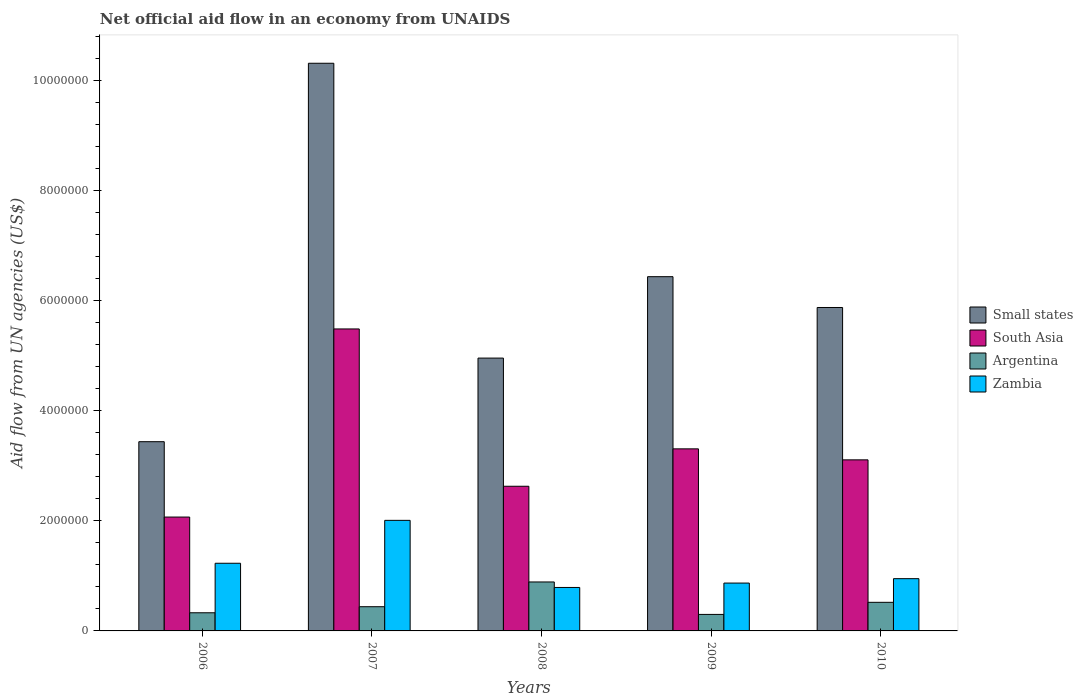Are the number of bars per tick equal to the number of legend labels?
Provide a succinct answer. Yes. Are the number of bars on each tick of the X-axis equal?
Your answer should be compact. Yes. What is the label of the 3rd group of bars from the left?
Keep it short and to the point. 2008. What is the net official aid flow in South Asia in 2007?
Make the answer very short. 5.49e+06. Across all years, what is the maximum net official aid flow in Argentina?
Give a very brief answer. 8.90e+05. Across all years, what is the minimum net official aid flow in Zambia?
Keep it short and to the point. 7.90e+05. What is the total net official aid flow in South Asia in the graph?
Provide a succinct answer. 1.66e+07. What is the difference between the net official aid flow in South Asia in 2007 and that in 2010?
Keep it short and to the point. 2.38e+06. What is the difference between the net official aid flow in Zambia in 2008 and the net official aid flow in Small states in 2006?
Ensure brevity in your answer.  -2.65e+06. What is the average net official aid flow in Zambia per year?
Make the answer very short. 1.17e+06. In the year 2007, what is the difference between the net official aid flow in Argentina and net official aid flow in Zambia?
Your answer should be very brief. -1.57e+06. In how many years, is the net official aid flow in South Asia greater than 10000000 US$?
Make the answer very short. 0. What is the ratio of the net official aid flow in South Asia in 2006 to that in 2008?
Offer a terse response. 0.79. Is the net official aid flow in Small states in 2006 less than that in 2008?
Give a very brief answer. Yes. What is the difference between the highest and the second highest net official aid flow in Small states?
Make the answer very short. 3.88e+06. What is the difference between the highest and the lowest net official aid flow in Argentina?
Provide a short and direct response. 5.90e+05. What does the 4th bar from the right in 2006 represents?
Your answer should be compact. Small states. How many bars are there?
Make the answer very short. 20. How many years are there in the graph?
Keep it short and to the point. 5. What is the difference between two consecutive major ticks on the Y-axis?
Keep it short and to the point. 2.00e+06. Where does the legend appear in the graph?
Ensure brevity in your answer.  Center right. What is the title of the graph?
Offer a terse response. Net official aid flow in an economy from UNAIDS. Does "Netherlands" appear as one of the legend labels in the graph?
Offer a very short reply. No. What is the label or title of the Y-axis?
Your response must be concise. Aid flow from UN agencies (US$). What is the Aid flow from UN agencies (US$) of Small states in 2006?
Offer a terse response. 3.44e+06. What is the Aid flow from UN agencies (US$) in South Asia in 2006?
Your answer should be compact. 2.07e+06. What is the Aid flow from UN agencies (US$) of Argentina in 2006?
Provide a short and direct response. 3.30e+05. What is the Aid flow from UN agencies (US$) in Zambia in 2006?
Give a very brief answer. 1.23e+06. What is the Aid flow from UN agencies (US$) of Small states in 2007?
Your answer should be compact. 1.03e+07. What is the Aid flow from UN agencies (US$) of South Asia in 2007?
Your response must be concise. 5.49e+06. What is the Aid flow from UN agencies (US$) of Argentina in 2007?
Ensure brevity in your answer.  4.40e+05. What is the Aid flow from UN agencies (US$) of Zambia in 2007?
Your answer should be compact. 2.01e+06. What is the Aid flow from UN agencies (US$) in Small states in 2008?
Offer a very short reply. 4.96e+06. What is the Aid flow from UN agencies (US$) of South Asia in 2008?
Give a very brief answer. 2.63e+06. What is the Aid flow from UN agencies (US$) of Argentina in 2008?
Make the answer very short. 8.90e+05. What is the Aid flow from UN agencies (US$) in Zambia in 2008?
Offer a terse response. 7.90e+05. What is the Aid flow from UN agencies (US$) in Small states in 2009?
Provide a short and direct response. 6.44e+06. What is the Aid flow from UN agencies (US$) in South Asia in 2009?
Offer a very short reply. 3.31e+06. What is the Aid flow from UN agencies (US$) of Zambia in 2009?
Offer a terse response. 8.70e+05. What is the Aid flow from UN agencies (US$) of Small states in 2010?
Your answer should be very brief. 5.88e+06. What is the Aid flow from UN agencies (US$) in South Asia in 2010?
Provide a succinct answer. 3.11e+06. What is the Aid flow from UN agencies (US$) in Argentina in 2010?
Your answer should be compact. 5.20e+05. What is the Aid flow from UN agencies (US$) in Zambia in 2010?
Keep it short and to the point. 9.50e+05. Across all years, what is the maximum Aid flow from UN agencies (US$) in Small states?
Make the answer very short. 1.03e+07. Across all years, what is the maximum Aid flow from UN agencies (US$) of South Asia?
Your response must be concise. 5.49e+06. Across all years, what is the maximum Aid flow from UN agencies (US$) in Argentina?
Make the answer very short. 8.90e+05. Across all years, what is the maximum Aid flow from UN agencies (US$) in Zambia?
Ensure brevity in your answer.  2.01e+06. Across all years, what is the minimum Aid flow from UN agencies (US$) in Small states?
Give a very brief answer. 3.44e+06. Across all years, what is the minimum Aid flow from UN agencies (US$) of South Asia?
Your answer should be very brief. 2.07e+06. Across all years, what is the minimum Aid flow from UN agencies (US$) in Argentina?
Provide a short and direct response. 3.00e+05. Across all years, what is the minimum Aid flow from UN agencies (US$) in Zambia?
Provide a succinct answer. 7.90e+05. What is the total Aid flow from UN agencies (US$) in Small states in the graph?
Offer a terse response. 3.10e+07. What is the total Aid flow from UN agencies (US$) in South Asia in the graph?
Your response must be concise. 1.66e+07. What is the total Aid flow from UN agencies (US$) in Argentina in the graph?
Give a very brief answer. 2.48e+06. What is the total Aid flow from UN agencies (US$) of Zambia in the graph?
Provide a short and direct response. 5.85e+06. What is the difference between the Aid flow from UN agencies (US$) in Small states in 2006 and that in 2007?
Give a very brief answer. -6.88e+06. What is the difference between the Aid flow from UN agencies (US$) in South Asia in 2006 and that in 2007?
Offer a terse response. -3.42e+06. What is the difference between the Aid flow from UN agencies (US$) of Argentina in 2006 and that in 2007?
Make the answer very short. -1.10e+05. What is the difference between the Aid flow from UN agencies (US$) in Zambia in 2006 and that in 2007?
Ensure brevity in your answer.  -7.80e+05. What is the difference between the Aid flow from UN agencies (US$) of Small states in 2006 and that in 2008?
Your answer should be compact. -1.52e+06. What is the difference between the Aid flow from UN agencies (US$) in South Asia in 2006 and that in 2008?
Your answer should be very brief. -5.60e+05. What is the difference between the Aid flow from UN agencies (US$) of Argentina in 2006 and that in 2008?
Keep it short and to the point. -5.60e+05. What is the difference between the Aid flow from UN agencies (US$) in Zambia in 2006 and that in 2008?
Offer a very short reply. 4.40e+05. What is the difference between the Aid flow from UN agencies (US$) in South Asia in 2006 and that in 2009?
Provide a succinct answer. -1.24e+06. What is the difference between the Aid flow from UN agencies (US$) in Small states in 2006 and that in 2010?
Make the answer very short. -2.44e+06. What is the difference between the Aid flow from UN agencies (US$) of South Asia in 2006 and that in 2010?
Your answer should be compact. -1.04e+06. What is the difference between the Aid flow from UN agencies (US$) of Argentina in 2006 and that in 2010?
Your answer should be compact. -1.90e+05. What is the difference between the Aid flow from UN agencies (US$) of Zambia in 2006 and that in 2010?
Make the answer very short. 2.80e+05. What is the difference between the Aid flow from UN agencies (US$) in Small states in 2007 and that in 2008?
Your answer should be compact. 5.36e+06. What is the difference between the Aid flow from UN agencies (US$) in South Asia in 2007 and that in 2008?
Give a very brief answer. 2.86e+06. What is the difference between the Aid flow from UN agencies (US$) of Argentina in 2007 and that in 2008?
Keep it short and to the point. -4.50e+05. What is the difference between the Aid flow from UN agencies (US$) of Zambia in 2007 and that in 2008?
Your response must be concise. 1.22e+06. What is the difference between the Aid flow from UN agencies (US$) in Small states in 2007 and that in 2009?
Your answer should be very brief. 3.88e+06. What is the difference between the Aid flow from UN agencies (US$) in South Asia in 2007 and that in 2009?
Your answer should be very brief. 2.18e+06. What is the difference between the Aid flow from UN agencies (US$) of Zambia in 2007 and that in 2009?
Provide a succinct answer. 1.14e+06. What is the difference between the Aid flow from UN agencies (US$) in Small states in 2007 and that in 2010?
Make the answer very short. 4.44e+06. What is the difference between the Aid flow from UN agencies (US$) in South Asia in 2007 and that in 2010?
Offer a very short reply. 2.38e+06. What is the difference between the Aid flow from UN agencies (US$) of Zambia in 2007 and that in 2010?
Provide a succinct answer. 1.06e+06. What is the difference between the Aid flow from UN agencies (US$) in Small states in 2008 and that in 2009?
Give a very brief answer. -1.48e+06. What is the difference between the Aid flow from UN agencies (US$) of South Asia in 2008 and that in 2009?
Ensure brevity in your answer.  -6.80e+05. What is the difference between the Aid flow from UN agencies (US$) in Argentina in 2008 and that in 2009?
Offer a very short reply. 5.90e+05. What is the difference between the Aid flow from UN agencies (US$) in Zambia in 2008 and that in 2009?
Offer a terse response. -8.00e+04. What is the difference between the Aid flow from UN agencies (US$) of Small states in 2008 and that in 2010?
Keep it short and to the point. -9.20e+05. What is the difference between the Aid flow from UN agencies (US$) in South Asia in 2008 and that in 2010?
Offer a terse response. -4.80e+05. What is the difference between the Aid flow from UN agencies (US$) in Small states in 2009 and that in 2010?
Provide a succinct answer. 5.60e+05. What is the difference between the Aid flow from UN agencies (US$) in South Asia in 2009 and that in 2010?
Give a very brief answer. 2.00e+05. What is the difference between the Aid flow from UN agencies (US$) in Zambia in 2009 and that in 2010?
Your response must be concise. -8.00e+04. What is the difference between the Aid flow from UN agencies (US$) of Small states in 2006 and the Aid flow from UN agencies (US$) of South Asia in 2007?
Offer a terse response. -2.05e+06. What is the difference between the Aid flow from UN agencies (US$) in Small states in 2006 and the Aid flow from UN agencies (US$) in Zambia in 2007?
Offer a very short reply. 1.43e+06. What is the difference between the Aid flow from UN agencies (US$) in South Asia in 2006 and the Aid flow from UN agencies (US$) in Argentina in 2007?
Give a very brief answer. 1.63e+06. What is the difference between the Aid flow from UN agencies (US$) of South Asia in 2006 and the Aid flow from UN agencies (US$) of Zambia in 2007?
Offer a very short reply. 6.00e+04. What is the difference between the Aid flow from UN agencies (US$) in Argentina in 2006 and the Aid flow from UN agencies (US$) in Zambia in 2007?
Your answer should be very brief. -1.68e+06. What is the difference between the Aid flow from UN agencies (US$) in Small states in 2006 and the Aid flow from UN agencies (US$) in South Asia in 2008?
Give a very brief answer. 8.10e+05. What is the difference between the Aid flow from UN agencies (US$) of Small states in 2006 and the Aid flow from UN agencies (US$) of Argentina in 2008?
Give a very brief answer. 2.55e+06. What is the difference between the Aid flow from UN agencies (US$) of Small states in 2006 and the Aid flow from UN agencies (US$) of Zambia in 2008?
Your response must be concise. 2.65e+06. What is the difference between the Aid flow from UN agencies (US$) of South Asia in 2006 and the Aid flow from UN agencies (US$) of Argentina in 2008?
Keep it short and to the point. 1.18e+06. What is the difference between the Aid flow from UN agencies (US$) of South Asia in 2006 and the Aid flow from UN agencies (US$) of Zambia in 2008?
Your response must be concise. 1.28e+06. What is the difference between the Aid flow from UN agencies (US$) of Argentina in 2006 and the Aid flow from UN agencies (US$) of Zambia in 2008?
Your answer should be very brief. -4.60e+05. What is the difference between the Aid flow from UN agencies (US$) of Small states in 2006 and the Aid flow from UN agencies (US$) of South Asia in 2009?
Your response must be concise. 1.30e+05. What is the difference between the Aid flow from UN agencies (US$) in Small states in 2006 and the Aid flow from UN agencies (US$) in Argentina in 2009?
Offer a very short reply. 3.14e+06. What is the difference between the Aid flow from UN agencies (US$) in Small states in 2006 and the Aid flow from UN agencies (US$) in Zambia in 2009?
Give a very brief answer. 2.57e+06. What is the difference between the Aid flow from UN agencies (US$) of South Asia in 2006 and the Aid flow from UN agencies (US$) of Argentina in 2009?
Provide a short and direct response. 1.77e+06. What is the difference between the Aid flow from UN agencies (US$) in South Asia in 2006 and the Aid flow from UN agencies (US$) in Zambia in 2009?
Keep it short and to the point. 1.20e+06. What is the difference between the Aid flow from UN agencies (US$) of Argentina in 2006 and the Aid flow from UN agencies (US$) of Zambia in 2009?
Offer a very short reply. -5.40e+05. What is the difference between the Aid flow from UN agencies (US$) of Small states in 2006 and the Aid flow from UN agencies (US$) of Argentina in 2010?
Provide a succinct answer. 2.92e+06. What is the difference between the Aid flow from UN agencies (US$) in Small states in 2006 and the Aid flow from UN agencies (US$) in Zambia in 2010?
Keep it short and to the point. 2.49e+06. What is the difference between the Aid flow from UN agencies (US$) in South Asia in 2006 and the Aid flow from UN agencies (US$) in Argentina in 2010?
Your answer should be very brief. 1.55e+06. What is the difference between the Aid flow from UN agencies (US$) of South Asia in 2006 and the Aid flow from UN agencies (US$) of Zambia in 2010?
Offer a terse response. 1.12e+06. What is the difference between the Aid flow from UN agencies (US$) of Argentina in 2006 and the Aid flow from UN agencies (US$) of Zambia in 2010?
Keep it short and to the point. -6.20e+05. What is the difference between the Aid flow from UN agencies (US$) in Small states in 2007 and the Aid flow from UN agencies (US$) in South Asia in 2008?
Your response must be concise. 7.69e+06. What is the difference between the Aid flow from UN agencies (US$) of Small states in 2007 and the Aid flow from UN agencies (US$) of Argentina in 2008?
Provide a short and direct response. 9.43e+06. What is the difference between the Aid flow from UN agencies (US$) of Small states in 2007 and the Aid flow from UN agencies (US$) of Zambia in 2008?
Your answer should be very brief. 9.53e+06. What is the difference between the Aid flow from UN agencies (US$) in South Asia in 2007 and the Aid flow from UN agencies (US$) in Argentina in 2008?
Provide a short and direct response. 4.60e+06. What is the difference between the Aid flow from UN agencies (US$) in South Asia in 2007 and the Aid flow from UN agencies (US$) in Zambia in 2008?
Offer a very short reply. 4.70e+06. What is the difference between the Aid flow from UN agencies (US$) in Argentina in 2007 and the Aid flow from UN agencies (US$) in Zambia in 2008?
Your response must be concise. -3.50e+05. What is the difference between the Aid flow from UN agencies (US$) of Small states in 2007 and the Aid flow from UN agencies (US$) of South Asia in 2009?
Offer a terse response. 7.01e+06. What is the difference between the Aid flow from UN agencies (US$) in Small states in 2007 and the Aid flow from UN agencies (US$) in Argentina in 2009?
Provide a short and direct response. 1.00e+07. What is the difference between the Aid flow from UN agencies (US$) of Small states in 2007 and the Aid flow from UN agencies (US$) of Zambia in 2009?
Your answer should be compact. 9.45e+06. What is the difference between the Aid flow from UN agencies (US$) in South Asia in 2007 and the Aid flow from UN agencies (US$) in Argentina in 2009?
Provide a succinct answer. 5.19e+06. What is the difference between the Aid flow from UN agencies (US$) in South Asia in 2007 and the Aid flow from UN agencies (US$) in Zambia in 2009?
Keep it short and to the point. 4.62e+06. What is the difference between the Aid flow from UN agencies (US$) in Argentina in 2007 and the Aid flow from UN agencies (US$) in Zambia in 2009?
Give a very brief answer. -4.30e+05. What is the difference between the Aid flow from UN agencies (US$) of Small states in 2007 and the Aid flow from UN agencies (US$) of South Asia in 2010?
Give a very brief answer. 7.21e+06. What is the difference between the Aid flow from UN agencies (US$) of Small states in 2007 and the Aid flow from UN agencies (US$) of Argentina in 2010?
Your response must be concise. 9.80e+06. What is the difference between the Aid flow from UN agencies (US$) of Small states in 2007 and the Aid flow from UN agencies (US$) of Zambia in 2010?
Give a very brief answer. 9.37e+06. What is the difference between the Aid flow from UN agencies (US$) in South Asia in 2007 and the Aid flow from UN agencies (US$) in Argentina in 2010?
Provide a short and direct response. 4.97e+06. What is the difference between the Aid flow from UN agencies (US$) in South Asia in 2007 and the Aid flow from UN agencies (US$) in Zambia in 2010?
Offer a very short reply. 4.54e+06. What is the difference between the Aid flow from UN agencies (US$) of Argentina in 2007 and the Aid flow from UN agencies (US$) of Zambia in 2010?
Give a very brief answer. -5.10e+05. What is the difference between the Aid flow from UN agencies (US$) in Small states in 2008 and the Aid flow from UN agencies (US$) in South Asia in 2009?
Your answer should be compact. 1.65e+06. What is the difference between the Aid flow from UN agencies (US$) of Small states in 2008 and the Aid flow from UN agencies (US$) of Argentina in 2009?
Ensure brevity in your answer.  4.66e+06. What is the difference between the Aid flow from UN agencies (US$) in Small states in 2008 and the Aid flow from UN agencies (US$) in Zambia in 2009?
Ensure brevity in your answer.  4.09e+06. What is the difference between the Aid flow from UN agencies (US$) in South Asia in 2008 and the Aid flow from UN agencies (US$) in Argentina in 2009?
Make the answer very short. 2.33e+06. What is the difference between the Aid flow from UN agencies (US$) in South Asia in 2008 and the Aid flow from UN agencies (US$) in Zambia in 2009?
Ensure brevity in your answer.  1.76e+06. What is the difference between the Aid flow from UN agencies (US$) in Argentina in 2008 and the Aid flow from UN agencies (US$) in Zambia in 2009?
Your response must be concise. 2.00e+04. What is the difference between the Aid flow from UN agencies (US$) in Small states in 2008 and the Aid flow from UN agencies (US$) in South Asia in 2010?
Offer a terse response. 1.85e+06. What is the difference between the Aid flow from UN agencies (US$) of Small states in 2008 and the Aid flow from UN agencies (US$) of Argentina in 2010?
Your answer should be compact. 4.44e+06. What is the difference between the Aid flow from UN agencies (US$) in Small states in 2008 and the Aid flow from UN agencies (US$) in Zambia in 2010?
Your answer should be very brief. 4.01e+06. What is the difference between the Aid flow from UN agencies (US$) of South Asia in 2008 and the Aid flow from UN agencies (US$) of Argentina in 2010?
Keep it short and to the point. 2.11e+06. What is the difference between the Aid flow from UN agencies (US$) of South Asia in 2008 and the Aid flow from UN agencies (US$) of Zambia in 2010?
Offer a very short reply. 1.68e+06. What is the difference between the Aid flow from UN agencies (US$) in Small states in 2009 and the Aid flow from UN agencies (US$) in South Asia in 2010?
Ensure brevity in your answer.  3.33e+06. What is the difference between the Aid flow from UN agencies (US$) in Small states in 2009 and the Aid flow from UN agencies (US$) in Argentina in 2010?
Give a very brief answer. 5.92e+06. What is the difference between the Aid flow from UN agencies (US$) of Small states in 2009 and the Aid flow from UN agencies (US$) of Zambia in 2010?
Ensure brevity in your answer.  5.49e+06. What is the difference between the Aid flow from UN agencies (US$) of South Asia in 2009 and the Aid flow from UN agencies (US$) of Argentina in 2010?
Provide a succinct answer. 2.79e+06. What is the difference between the Aid flow from UN agencies (US$) in South Asia in 2009 and the Aid flow from UN agencies (US$) in Zambia in 2010?
Offer a terse response. 2.36e+06. What is the difference between the Aid flow from UN agencies (US$) in Argentina in 2009 and the Aid flow from UN agencies (US$) in Zambia in 2010?
Your answer should be compact. -6.50e+05. What is the average Aid flow from UN agencies (US$) of Small states per year?
Your answer should be compact. 6.21e+06. What is the average Aid flow from UN agencies (US$) in South Asia per year?
Offer a terse response. 3.32e+06. What is the average Aid flow from UN agencies (US$) of Argentina per year?
Your answer should be compact. 4.96e+05. What is the average Aid flow from UN agencies (US$) in Zambia per year?
Your answer should be very brief. 1.17e+06. In the year 2006, what is the difference between the Aid flow from UN agencies (US$) in Small states and Aid flow from UN agencies (US$) in South Asia?
Ensure brevity in your answer.  1.37e+06. In the year 2006, what is the difference between the Aid flow from UN agencies (US$) of Small states and Aid flow from UN agencies (US$) of Argentina?
Offer a terse response. 3.11e+06. In the year 2006, what is the difference between the Aid flow from UN agencies (US$) of Small states and Aid flow from UN agencies (US$) of Zambia?
Provide a succinct answer. 2.21e+06. In the year 2006, what is the difference between the Aid flow from UN agencies (US$) in South Asia and Aid flow from UN agencies (US$) in Argentina?
Your answer should be compact. 1.74e+06. In the year 2006, what is the difference between the Aid flow from UN agencies (US$) in South Asia and Aid flow from UN agencies (US$) in Zambia?
Your answer should be compact. 8.40e+05. In the year 2006, what is the difference between the Aid flow from UN agencies (US$) of Argentina and Aid flow from UN agencies (US$) of Zambia?
Provide a succinct answer. -9.00e+05. In the year 2007, what is the difference between the Aid flow from UN agencies (US$) in Small states and Aid flow from UN agencies (US$) in South Asia?
Give a very brief answer. 4.83e+06. In the year 2007, what is the difference between the Aid flow from UN agencies (US$) in Small states and Aid flow from UN agencies (US$) in Argentina?
Keep it short and to the point. 9.88e+06. In the year 2007, what is the difference between the Aid flow from UN agencies (US$) of Small states and Aid flow from UN agencies (US$) of Zambia?
Your answer should be very brief. 8.31e+06. In the year 2007, what is the difference between the Aid flow from UN agencies (US$) in South Asia and Aid flow from UN agencies (US$) in Argentina?
Your response must be concise. 5.05e+06. In the year 2007, what is the difference between the Aid flow from UN agencies (US$) in South Asia and Aid flow from UN agencies (US$) in Zambia?
Give a very brief answer. 3.48e+06. In the year 2007, what is the difference between the Aid flow from UN agencies (US$) of Argentina and Aid flow from UN agencies (US$) of Zambia?
Your answer should be very brief. -1.57e+06. In the year 2008, what is the difference between the Aid flow from UN agencies (US$) in Small states and Aid flow from UN agencies (US$) in South Asia?
Your response must be concise. 2.33e+06. In the year 2008, what is the difference between the Aid flow from UN agencies (US$) of Small states and Aid flow from UN agencies (US$) of Argentina?
Give a very brief answer. 4.07e+06. In the year 2008, what is the difference between the Aid flow from UN agencies (US$) of Small states and Aid flow from UN agencies (US$) of Zambia?
Keep it short and to the point. 4.17e+06. In the year 2008, what is the difference between the Aid flow from UN agencies (US$) of South Asia and Aid flow from UN agencies (US$) of Argentina?
Provide a succinct answer. 1.74e+06. In the year 2008, what is the difference between the Aid flow from UN agencies (US$) of South Asia and Aid flow from UN agencies (US$) of Zambia?
Keep it short and to the point. 1.84e+06. In the year 2009, what is the difference between the Aid flow from UN agencies (US$) in Small states and Aid flow from UN agencies (US$) in South Asia?
Provide a short and direct response. 3.13e+06. In the year 2009, what is the difference between the Aid flow from UN agencies (US$) of Small states and Aid flow from UN agencies (US$) of Argentina?
Provide a short and direct response. 6.14e+06. In the year 2009, what is the difference between the Aid flow from UN agencies (US$) of Small states and Aid flow from UN agencies (US$) of Zambia?
Provide a succinct answer. 5.57e+06. In the year 2009, what is the difference between the Aid flow from UN agencies (US$) of South Asia and Aid flow from UN agencies (US$) of Argentina?
Your answer should be very brief. 3.01e+06. In the year 2009, what is the difference between the Aid flow from UN agencies (US$) of South Asia and Aid flow from UN agencies (US$) of Zambia?
Offer a very short reply. 2.44e+06. In the year 2009, what is the difference between the Aid flow from UN agencies (US$) in Argentina and Aid flow from UN agencies (US$) in Zambia?
Your answer should be compact. -5.70e+05. In the year 2010, what is the difference between the Aid flow from UN agencies (US$) of Small states and Aid flow from UN agencies (US$) of South Asia?
Your response must be concise. 2.77e+06. In the year 2010, what is the difference between the Aid flow from UN agencies (US$) of Small states and Aid flow from UN agencies (US$) of Argentina?
Your response must be concise. 5.36e+06. In the year 2010, what is the difference between the Aid flow from UN agencies (US$) of Small states and Aid flow from UN agencies (US$) of Zambia?
Your answer should be compact. 4.93e+06. In the year 2010, what is the difference between the Aid flow from UN agencies (US$) of South Asia and Aid flow from UN agencies (US$) of Argentina?
Offer a terse response. 2.59e+06. In the year 2010, what is the difference between the Aid flow from UN agencies (US$) in South Asia and Aid flow from UN agencies (US$) in Zambia?
Keep it short and to the point. 2.16e+06. In the year 2010, what is the difference between the Aid flow from UN agencies (US$) of Argentina and Aid flow from UN agencies (US$) of Zambia?
Your answer should be very brief. -4.30e+05. What is the ratio of the Aid flow from UN agencies (US$) in Small states in 2006 to that in 2007?
Your answer should be very brief. 0.33. What is the ratio of the Aid flow from UN agencies (US$) of South Asia in 2006 to that in 2007?
Provide a succinct answer. 0.38. What is the ratio of the Aid flow from UN agencies (US$) in Zambia in 2006 to that in 2007?
Your answer should be compact. 0.61. What is the ratio of the Aid flow from UN agencies (US$) in Small states in 2006 to that in 2008?
Your answer should be compact. 0.69. What is the ratio of the Aid flow from UN agencies (US$) in South Asia in 2006 to that in 2008?
Give a very brief answer. 0.79. What is the ratio of the Aid flow from UN agencies (US$) in Argentina in 2006 to that in 2008?
Your answer should be compact. 0.37. What is the ratio of the Aid flow from UN agencies (US$) of Zambia in 2006 to that in 2008?
Ensure brevity in your answer.  1.56. What is the ratio of the Aid flow from UN agencies (US$) in Small states in 2006 to that in 2009?
Make the answer very short. 0.53. What is the ratio of the Aid flow from UN agencies (US$) of South Asia in 2006 to that in 2009?
Provide a succinct answer. 0.63. What is the ratio of the Aid flow from UN agencies (US$) of Argentina in 2006 to that in 2009?
Ensure brevity in your answer.  1.1. What is the ratio of the Aid flow from UN agencies (US$) of Zambia in 2006 to that in 2009?
Give a very brief answer. 1.41. What is the ratio of the Aid flow from UN agencies (US$) in Small states in 2006 to that in 2010?
Offer a very short reply. 0.58. What is the ratio of the Aid flow from UN agencies (US$) in South Asia in 2006 to that in 2010?
Give a very brief answer. 0.67. What is the ratio of the Aid flow from UN agencies (US$) of Argentina in 2006 to that in 2010?
Make the answer very short. 0.63. What is the ratio of the Aid flow from UN agencies (US$) in Zambia in 2006 to that in 2010?
Offer a very short reply. 1.29. What is the ratio of the Aid flow from UN agencies (US$) in Small states in 2007 to that in 2008?
Make the answer very short. 2.08. What is the ratio of the Aid flow from UN agencies (US$) of South Asia in 2007 to that in 2008?
Give a very brief answer. 2.09. What is the ratio of the Aid flow from UN agencies (US$) of Argentina in 2007 to that in 2008?
Ensure brevity in your answer.  0.49. What is the ratio of the Aid flow from UN agencies (US$) in Zambia in 2007 to that in 2008?
Keep it short and to the point. 2.54. What is the ratio of the Aid flow from UN agencies (US$) in Small states in 2007 to that in 2009?
Ensure brevity in your answer.  1.6. What is the ratio of the Aid flow from UN agencies (US$) of South Asia in 2007 to that in 2009?
Provide a short and direct response. 1.66. What is the ratio of the Aid flow from UN agencies (US$) of Argentina in 2007 to that in 2009?
Offer a very short reply. 1.47. What is the ratio of the Aid flow from UN agencies (US$) in Zambia in 2007 to that in 2009?
Offer a terse response. 2.31. What is the ratio of the Aid flow from UN agencies (US$) of Small states in 2007 to that in 2010?
Offer a very short reply. 1.76. What is the ratio of the Aid flow from UN agencies (US$) of South Asia in 2007 to that in 2010?
Your answer should be compact. 1.77. What is the ratio of the Aid flow from UN agencies (US$) of Argentina in 2007 to that in 2010?
Give a very brief answer. 0.85. What is the ratio of the Aid flow from UN agencies (US$) of Zambia in 2007 to that in 2010?
Offer a terse response. 2.12. What is the ratio of the Aid flow from UN agencies (US$) in Small states in 2008 to that in 2009?
Provide a short and direct response. 0.77. What is the ratio of the Aid flow from UN agencies (US$) of South Asia in 2008 to that in 2009?
Keep it short and to the point. 0.79. What is the ratio of the Aid flow from UN agencies (US$) in Argentina in 2008 to that in 2009?
Ensure brevity in your answer.  2.97. What is the ratio of the Aid flow from UN agencies (US$) in Zambia in 2008 to that in 2009?
Keep it short and to the point. 0.91. What is the ratio of the Aid flow from UN agencies (US$) of Small states in 2008 to that in 2010?
Give a very brief answer. 0.84. What is the ratio of the Aid flow from UN agencies (US$) in South Asia in 2008 to that in 2010?
Your answer should be very brief. 0.85. What is the ratio of the Aid flow from UN agencies (US$) in Argentina in 2008 to that in 2010?
Ensure brevity in your answer.  1.71. What is the ratio of the Aid flow from UN agencies (US$) of Zambia in 2008 to that in 2010?
Your answer should be very brief. 0.83. What is the ratio of the Aid flow from UN agencies (US$) in Small states in 2009 to that in 2010?
Offer a very short reply. 1.1. What is the ratio of the Aid flow from UN agencies (US$) of South Asia in 2009 to that in 2010?
Ensure brevity in your answer.  1.06. What is the ratio of the Aid flow from UN agencies (US$) in Argentina in 2009 to that in 2010?
Ensure brevity in your answer.  0.58. What is the ratio of the Aid flow from UN agencies (US$) of Zambia in 2009 to that in 2010?
Offer a terse response. 0.92. What is the difference between the highest and the second highest Aid flow from UN agencies (US$) of Small states?
Keep it short and to the point. 3.88e+06. What is the difference between the highest and the second highest Aid flow from UN agencies (US$) of South Asia?
Give a very brief answer. 2.18e+06. What is the difference between the highest and the second highest Aid flow from UN agencies (US$) in Zambia?
Your answer should be very brief. 7.80e+05. What is the difference between the highest and the lowest Aid flow from UN agencies (US$) in Small states?
Your answer should be compact. 6.88e+06. What is the difference between the highest and the lowest Aid flow from UN agencies (US$) in South Asia?
Your answer should be compact. 3.42e+06. What is the difference between the highest and the lowest Aid flow from UN agencies (US$) in Argentina?
Keep it short and to the point. 5.90e+05. What is the difference between the highest and the lowest Aid flow from UN agencies (US$) in Zambia?
Keep it short and to the point. 1.22e+06. 